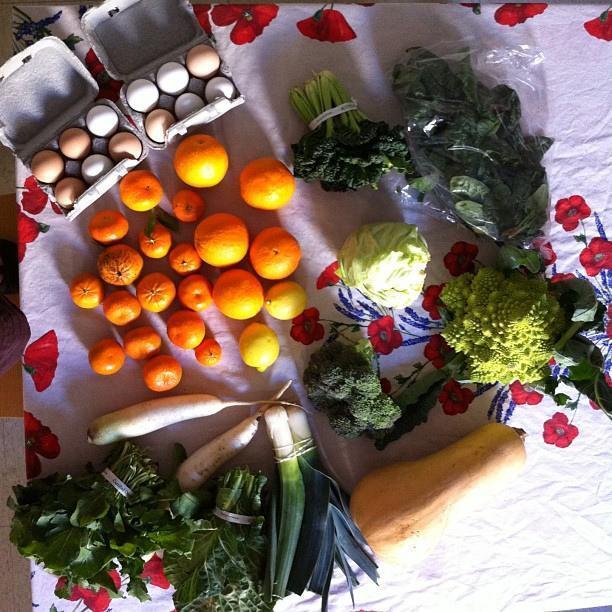How many brown eggs are there?
Give a very brief answer. 6. How many lemons are there?
Give a very brief answer. 2. How many oranges are visible?
Give a very brief answer. 5. How many broccolis are there?
Give a very brief answer. 3. How many people are sleeping on the bed?
Give a very brief answer. 0. 